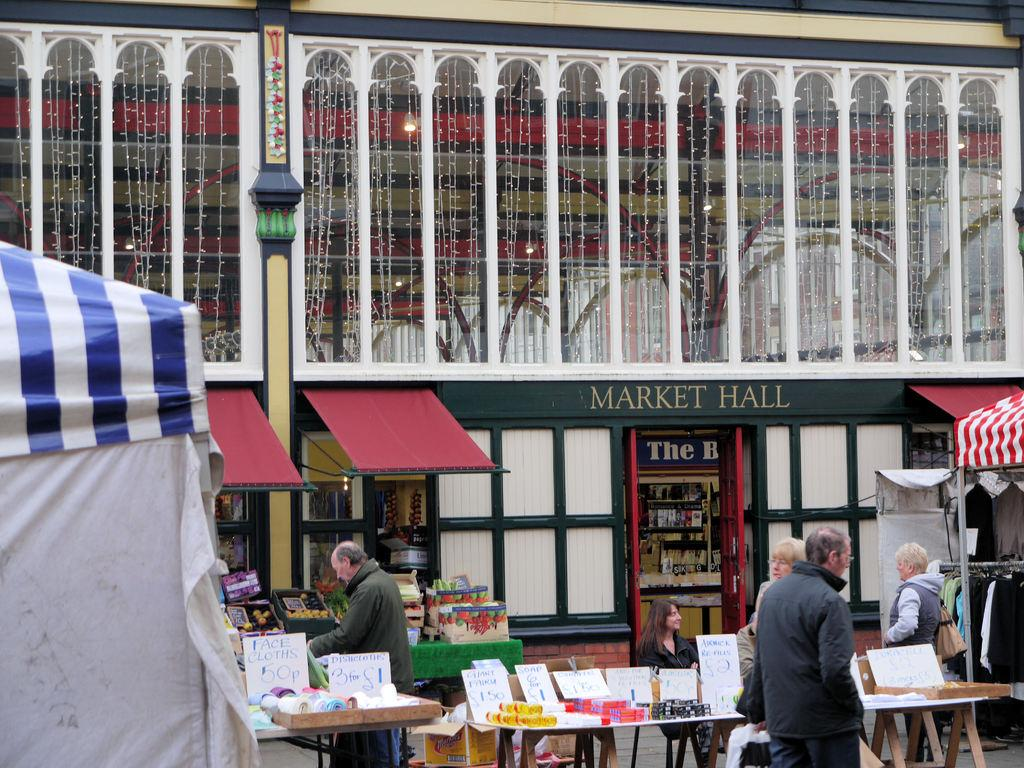What can be seen in the image? There are people standing in the image. What are the people standing near? There are tables in front of the people. What is visible in the background behind the people? There is a market hall behind the people. How many cords are hanging from the ceiling in the image? There are no cords visible in the image. What type of boats can be seen in the image? There are no boats present in the image. 